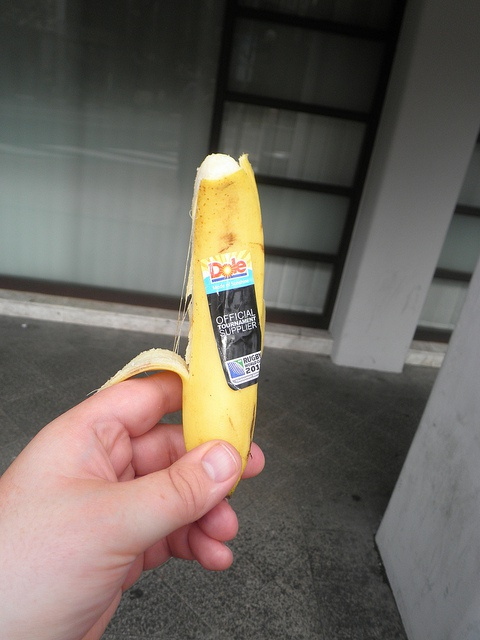Describe the objects in this image and their specific colors. I can see people in black, lightpink, brown, darkgray, and pink tones and banana in black, khaki, ivory, and gray tones in this image. 